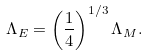<formula> <loc_0><loc_0><loc_500><loc_500>\Lambda _ { E } = \left ( \frac { 1 } { 4 } \right ) ^ { 1 / 3 } \Lambda _ { M } .</formula> 